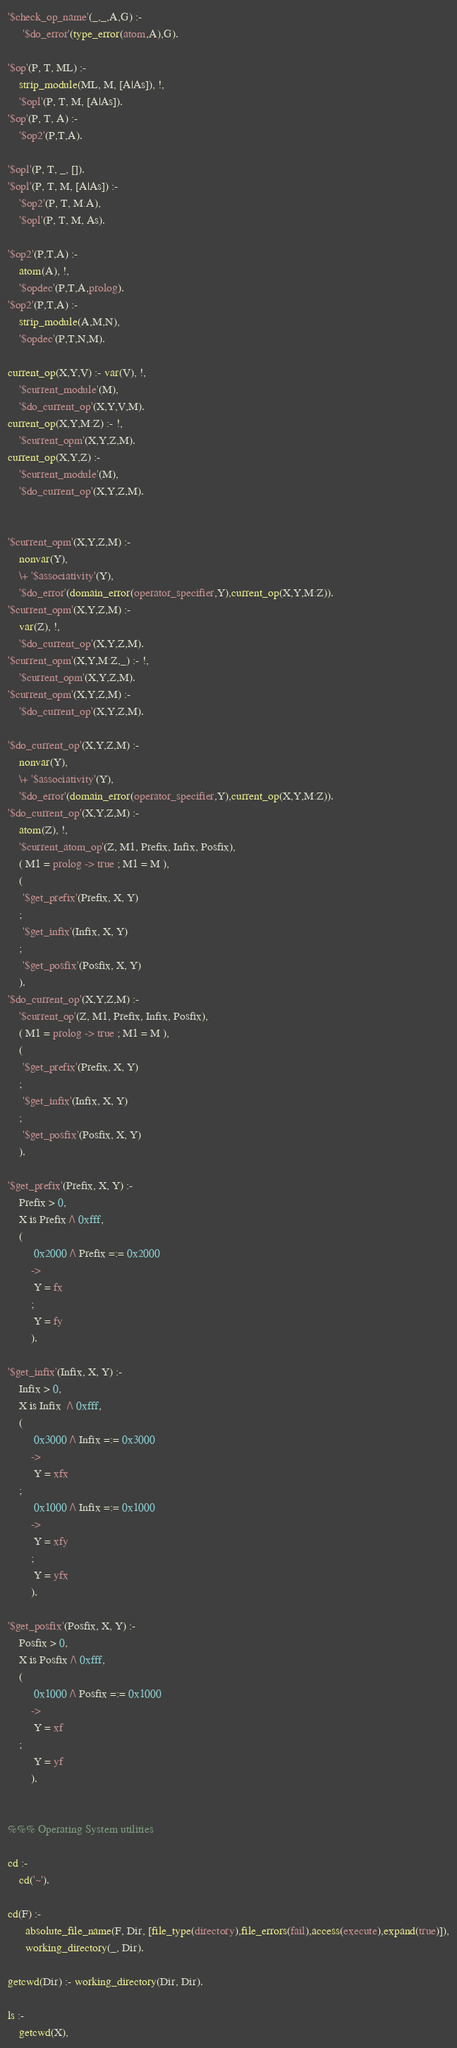<code> <loc_0><loc_0><loc_500><loc_500><_Prolog_>'$check_op_name'(_,_,A,G) :-
	 '$do_error'(type_error(atom,A),G).

'$op'(P, T, ML) :-
	strip_module(ML, M, [A|As]), !,
	'$opl'(P, T, M, [A|As]).
'$op'(P, T, A) :-
	'$op2'(P,T,A).

'$opl'(P, T, _, []).
'$opl'(P, T, M, [A|As]) :-
	'$op2'(P, T, M:A),
	'$opl'(P, T, M, As).

'$op2'(P,T,A) :-
	atom(A), !,
	'$opdec'(P,T,A,prolog).
'$op2'(P,T,A) :-
	strip_module(A,M,N),
	'$opdec'(P,T,N,M).

current_op(X,Y,V) :- var(V), !,
	'$current_module'(M),
	'$do_current_op'(X,Y,V,M).
current_op(X,Y,M:Z) :- !,
	'$current_opm'(X,Y,Z,M).
current_op(X,Y,Z) :-
	'$current_module'(M),
	'$do_current_op'(X,Y,Z,M).


'$current_opm'(X,Y,Z,M) :-
	nonvar(Y),
	\+ '$associativity'(Y),
	'$do_error'(domain_error(operator_specifier,Y),current_op(X,Y,M:Z)).
'$current_opm'(X,Y,Z,M) :-
	var(Z), !,
	'$do_current_op'(X,Y,Z,M).
'$current_opm'(X,Y,M:Z,_) :- !,
	'$current_opm'(X,Y,Z,M).
'$current_opm'(X,Y,Z,M) :-
	'$do_current_op'(X,Y,Z,M).

'$do_current_op'(X,Y,Z,M) :-
	nonvar(Y),
	\+ '$associativity'(Y),
	'$do_error'(domain_error(operator_specifier,Y),current_op(X,Y,M:Z)).
'$do_current_op'(X,Y,Z,M) :-
	atom(Z), !,
	'$current_atom_op'(Z, M1, Prefix, Infix, Posfix),
	( M1 = prolog -> true ; M1 = M ),
	(
	 '$get_prefix'(Prefix, X, Y)
	;
	 '$get_infix'(Infix, X, Y)
	;
	 '$get_posfix'(Posfix, X, Y)
	).
'$do_current_op'(X,Y,Z,M) :-
	'$current_op'(Z, M1, Prefix, Infix, Posfix),
	( M1 = prolog -> true ; M1 = M ),
	(
	 '$get_prefix'(Prefix, X, Y)
	;
	 '$get_infix'(Infix, X, Y)
	;
	 '$get_posfix'(Posfix, X, Y)
	).

'$get_prefix'(Prefix, X, Y) :-
	Prefix > 0,
	X is Prefix /\ 0xfff,
	(
         0x2000 /\ Prefix =:= 0x2000
        ->
         Y = fx
        ;
         Y = fy
        ).

'$get_infix'(Infix, X, Y) :-
	Infix > 0,
	X is Infix  /\ 0xfff,
	(
         0x3000 /\ Infix =:= 0x3000
        ->
         Y = xfx
	;
         0x1000 /\ Infix =:= 0x1000
        ->
         Y = xfy
        ;
         Y = yfx
        ).

'$get_posfix'(Posfix, X, Y) :-
	Posfix > 0,
	X is Posfix /\ 0xfff,
	(
         0x1000 /\ Posfix =:= 0x1000
        ->
         Y = xf
	;
         Y = yf
        ).


%%% Operating System utilities

cd :-
	cd('~').

cd(F) :-
      absolute_file_name(F, Dir, [file_type(directory),file_errors(fail),access(execute),expand(true)]),
      working_directory(_, Dir).

getcwd(Dir) :- working_directory(Dir, Dir).

ls :-
	getcwd(X),</code> 